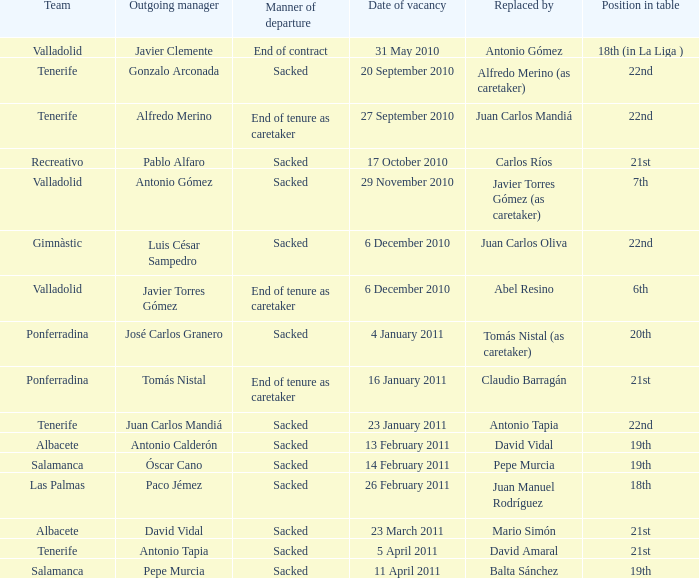Parse the table in full. {'header': ['Team', 'Outgoing manager', 'Manner of departure', 'Date of vacancy', 'Replaced by', 'Position in table'], 'rows': [['Valladolid', 'Javier Clemente', 'End of contract', '31 May 2010', 'Antonio Gómez', '18th (in La Liga )'], ['Tenerife', 'Gonzalo Arconada', 'Sacked', '20 September 2010', 'Alfredo Merino (as caretaker)', '22nd'], ['Tenerife', 'Alfredo Merino', 'End of tenure as caretaker', '27 September 2010', 'Juan Carlos Mandiá', '22nd'], ['Recreativo', 'Pablo Alfaro', 'Sacked', '17 October 2010', 'Carlos Ríos', '21st'], ['Valladolid', 'Antonio Gómez', 'Sacked', '29 November 2010', 'Javier Torres Gómez (as caretaker)', '7th'], ['Gimnàstic', 'Luis César Sampedro', 'Sacked', '6 December 2010', 'Juan Carlos Oliva', '22nd'], ['Valladolid', 'Javier Torres Gómez', 'End of tenure as caretaker', '6 December 2010', 'Abel Resino', '6th'], ['Ponferradina', 'José Carlos Granero', 'Sacked', '4 January 2011', 'Tomás Nistal (as caretaker)', '20th'], ['Ponferradina', 'Tomás Nistal', 'End of tenure as caretaker', '16 January 2011', 'Claudio Barragán', '21st'], ['Tenerife', 'Juan Carlos Mandiá', 'Sacked', '23 January 2011', 'Antonio Tapia', '22nd'], ['Albacete', 'Antonio Calderón', 'Sacked', '13 February 2011', 'David Vidal', '19th'], ['Salamanca', 'Óscar Cano', 'Sacked', '14 February 2011', 'Pepe Murcia', '19th'], ['Las Palmas', 'Paco Jémez', 'Sacked', '26 February 2011', 'Juan Manuel Rodríguez', '18th'], ['Albacete', 'David Vidal', 'Sacked', '23 March 2011', 'Mario Simón', '21st'], ['Tenerife', 'Antonio Tapia', 'Sacked', '5 April 2011', 'David Amaral', '21st'], ['Salamanca', 'Pepe Murcia', 'Sacked', '11 April 2011', 'Balta Sánchez', '19th']]} What was the appointment date for outgoing manager luis césar sampedro 6 December 2010. 